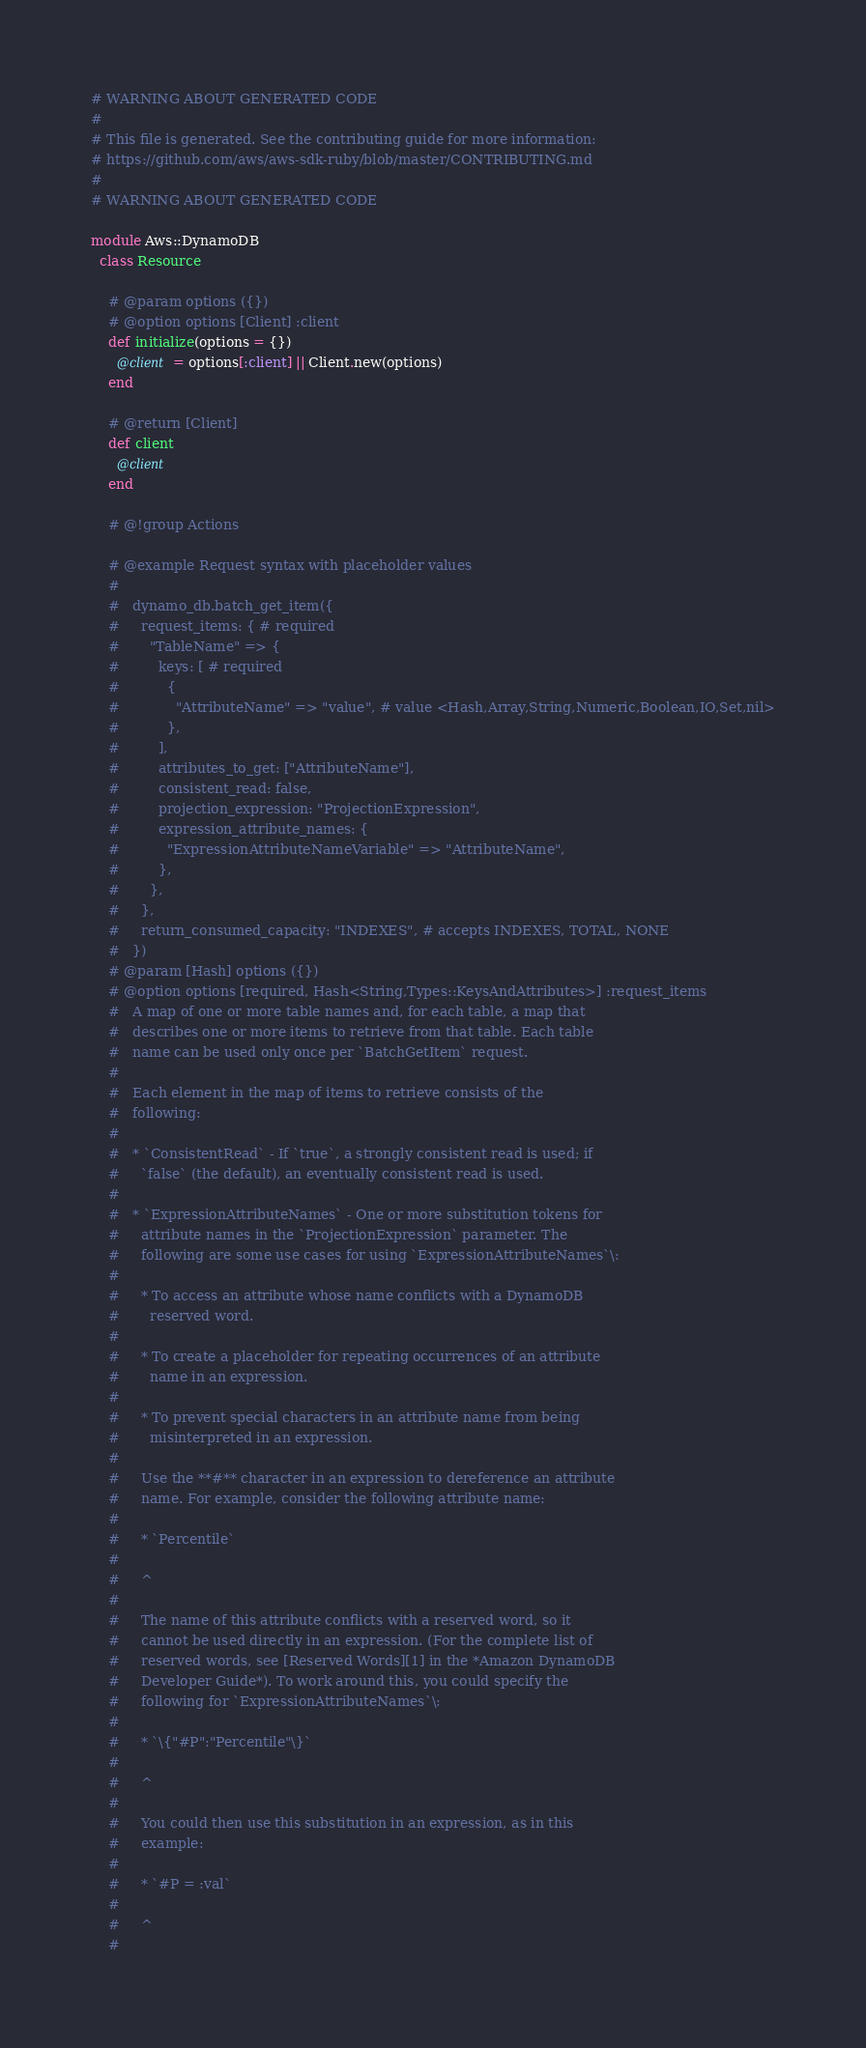<code> <loc_0><loc_0><loc_500><loc_500><_Ruby_># WARNING ABOUT GENERATED CODE
#
# This file is generated. See the contributing guide for more information:
# https://github.com/aws/aws-sdk-ruby/blob/master/CONTRIBUTING.md
#
# WARNING ABOUT GENERATED CODE

module Aws::DynamoDB
  class Resource

    # @param options ({})
    # @option options [Client] :client
    def initialize(options = {})
      @client = options[:client] || Client.new(options)
    end

    # @return [Client]
    def client
      @client
    end

    # @!group Actions

    # @example Request syntax with placeholder values
    #
    #   dynamo_db.batch_get_item({
    #     request_items: { # required
    #       "TableName" => {
    #         keys: [ # required
    #           {
    #             "AttributeName" => "value", # value <Hash,Array,String,Numeric,Boolean,IO,Set,nil>
    #           },
    #         ],
    #         attributes_to_get: ["AttributeName"],
    #         consistent_read: false,
    #         projection_expression: "ProjectionExpression",
    #         expression_attribute_names: {
    #           "ExpressionAttributeNameVariable" => "AttributeName",
    #         },
    #       },
    #     },
    #     return_consumed_capacity: "INDEXES", # accepts INDEXES, TOTAL, NONE
    #   })
    # @param [Hash] options ({})
    # @option options [required, Hash<String,Types::KeysAndAttributes>] :request_items
    #   A map of one or more table names and, for each table, a map that
    #   describes one or more items to retrieve from that table. Each table
    #   name can be used only once per `BatchGetItem` request.
    #
    #   Each element in the map of items to retrieve consists of the
    #   following:
    #
    #   * `ConsistentRead` - If `true`, a strongly consistent read is used; if
    #     `false` (the default), an eventually consistent read is used.
    #
    #   * `ExpressionAttributeNames` - One or more substitution tokens for
    #     attribute names in the `ProjectionExpression` parameter. The
    #     following are some use cases for using `ExpressionAttributeNames`\:
    #
    #     * To access an attribute whose name conflicts with a DynamoDB
    #       reserved word.
    #
    #     * To create a placeholder for repeating occurrences of an attribute
    #       name in an expression.
    #
    #     * To prevent special characters in an attribute name from being
    #       misinterpreted in an expression.
    #
    #     Use the **#** character in an expression to dereference an attribute
    #     name. For example, consider the following attribute name:
    #
    #     * `Percentile`
    #
    #     ^
    #
    #     The name of this attribute conflicts with a reserved word, so it
    #     cannot be used directly in an expression. (For the complete list of
    #     reserved words, see [Reserved Words][1] in the *Amazon DynamoDB
    #     Developer Guide*). To work around this, you could specify the
    #     following for `ExpressionAttributeNames`\:
    #
    #     * `\{"#P":"Percentile"\}`
    #
    #     ^
    #
    #     You could then use this substitution in an expression, as in this
    #     example:
    #
    #     * `#P = :val`
    #
    #     ^
    #</code> 